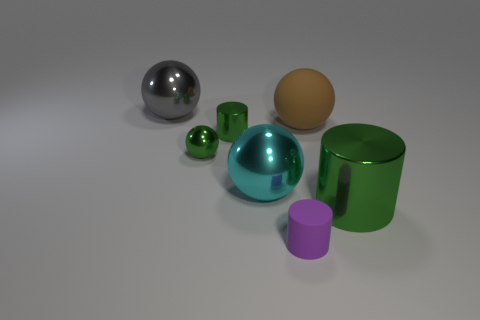Subtract all big balls. How many balls are left? 1 Subtract all brown spheres. How many spheres are left? 3 Add 1 gray cubes. How many objects exist? 8 Subtract all cylinders. How many objects are left? 4 Subtract 3 cylinders. How many cylinders are left? 0 Subtract all blue cylinders. Subtract all yellow cubes. How many cylinders are left? 3 Subtract all cyan blocks. How many red cylinders are left? 0 Subtract all green balls. Subtract all big gray metal things. How many objects are left? 5 Add 1 cyan metal spheres. How many cyan metal spheres are left? 2 Add 2 metallic balls. How many metallic balls exist? 5 